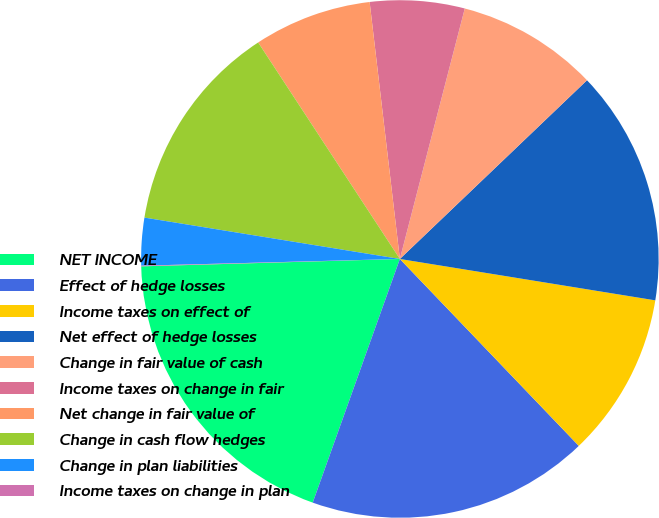Convert chart to OTSL. <chart><loc_0><loc_0><loc_500><loc_500><pie_chart><fcel>NET INCOME<fcel>Effect of hedge losses<fcel>Income taxes on effect of<fcel>Net effect of hedge losses<fcel>Change in fair value of cash<fcel>Income taxes on change in fair<fcel>Net change in fair value of<fcel>Change in cash flow hedges<fcel>Change in plan liabilities<fcel>Income taxes on change in plan<nl><fcel>19.08%<fcel>17.62%<fcel>10.29%<fcel>14.69%<fcel>8.83%<fcel>5.9%<fcel>7.36%<fcel>13.22%<fcel>2.97%<fcel>0.04%<nl></chart> 